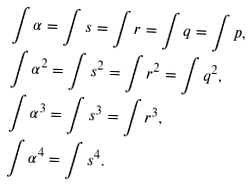Convert formula to latex. <formula><loc_0><loc_0><loc_500><loc_500>& \int \alpha = \int s = \int r = \int q = \int p , \\ & \int \alpha ^ { 2 } = \int s ^ { 2 } = \int r ^ { 2 } = \int q ^ { 2 } , \\ & \int \alpha ^ { 3 } = \int s ^ { 3 } = \int r ^ { 3 } , \\ & \int \alpha ^ { 4 } = \int s ^ { 4 } .</formula> 